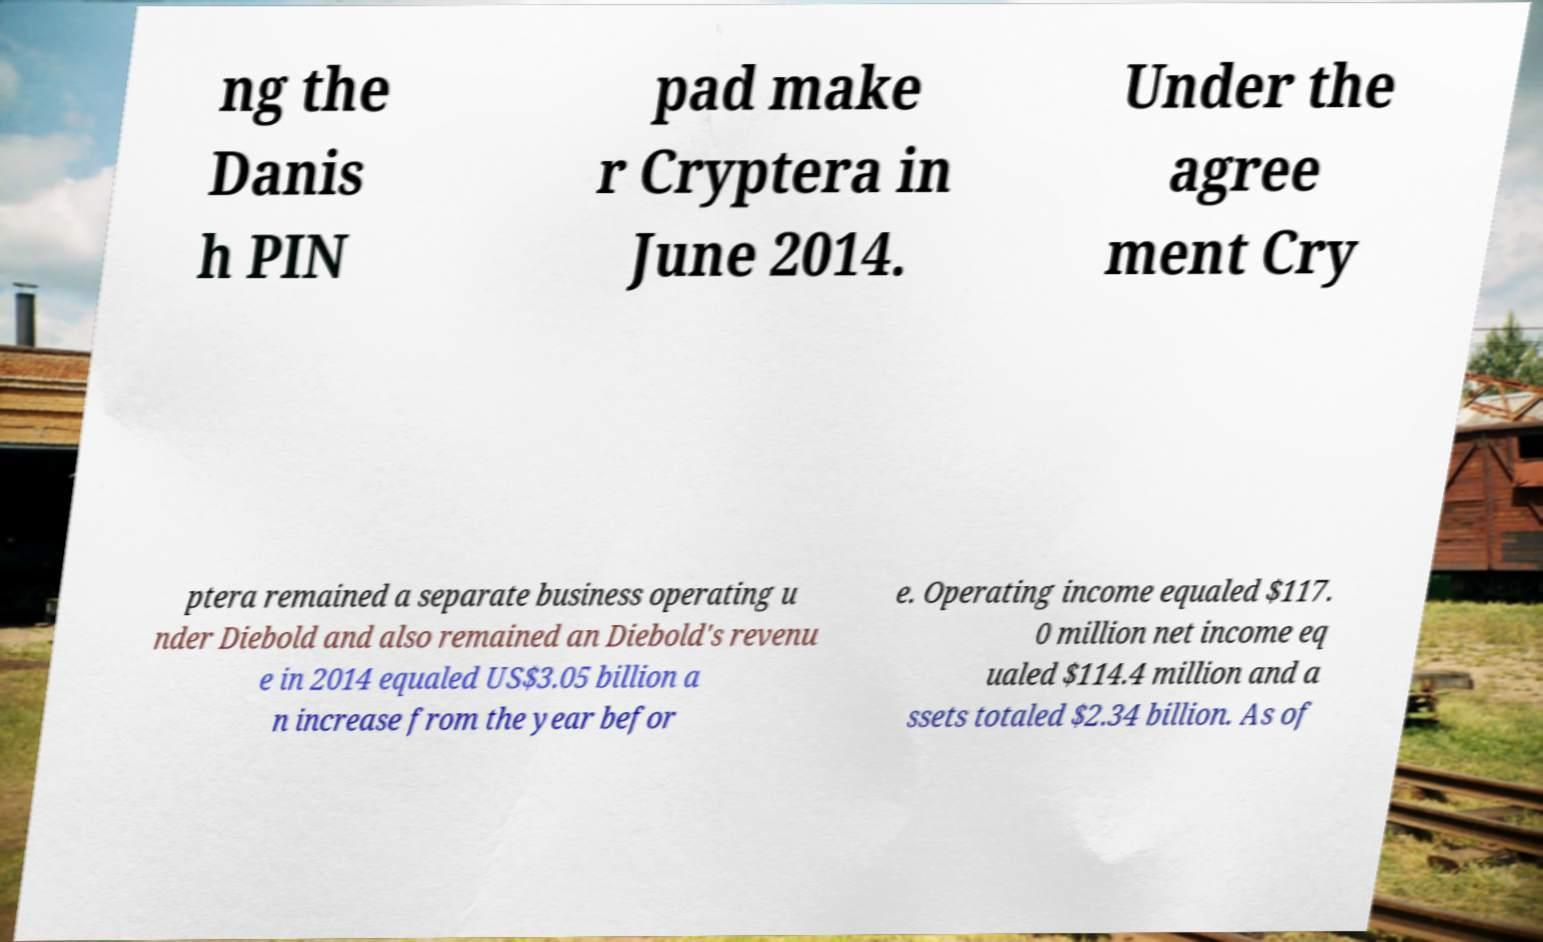For documentation purposes, I need the text within this image transcribed. Could you provide that? ng the Danis h PIN pad make r Cryptera in June 2014. Under the agree ment Cry ptera remained a separate business operating u nder Diebold and also remained an Diebold's revenu e in 2014 equaled US$3.05 billion a n increase from the year befor e. Operating income equaled $117. 0 million net income eq ualed $114.4 million and a ssets totaled $2.34 billion. As of 